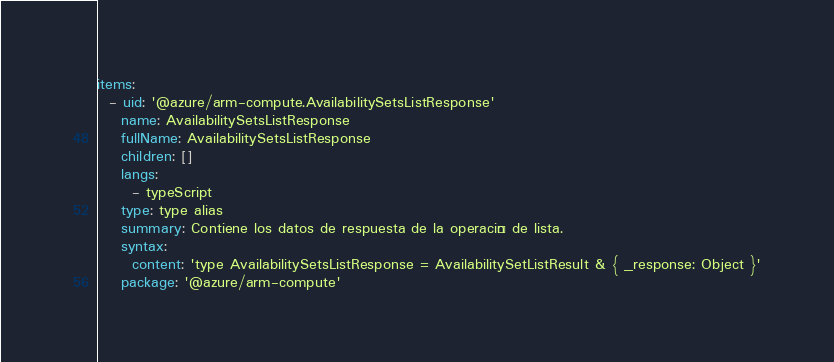<code> <loc_0><loc_0><loc_500><loc_500><_YAML_>items:
  - uid: '@azure/arm-compute.AvailabilitySetsListResponse'
    name: AvailabilitySetsListResponse
    fullName: AvailabilitySetsListResponse
    children: []
    langs:
      - typeScript
    type: type alias
    summary: Contiene los datos de respuesta de la operación de lista.
    syntax:
      content: 'type AvailabilitySetsListResponse = AvailabilitySetListResult & { _response: Object }'
    package: '@azure/arm-compute'</code> 